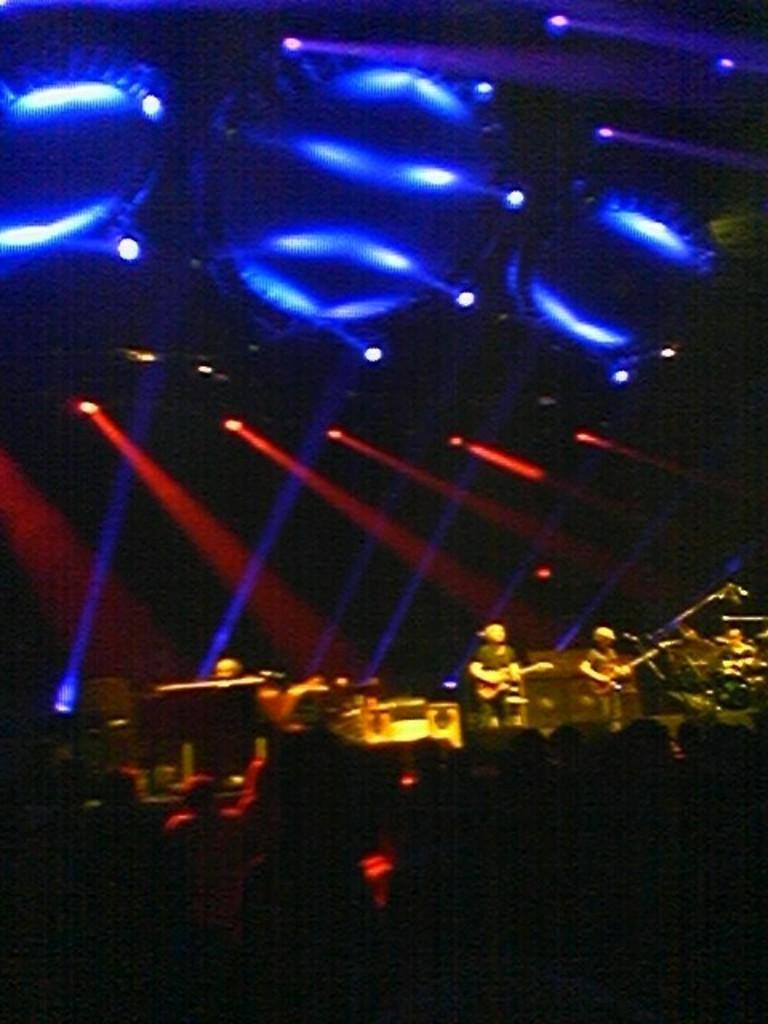What is the main subject of the image? The main subject of the image is a group of people. What are the people in the image doing? The presence of musical instruments suggests that the people might be playing music. What can be seen in the background or surrounding the people? Lights are visible in the image. Are there any other objects or items in the image? Yes, there are some objects in the image. Can you tell me how many cups are on the island in the image? There is no island or cup present in the image. What type of battle is taking place in the image? There is no battle present in the image; it features a group of people and musical instruments. 